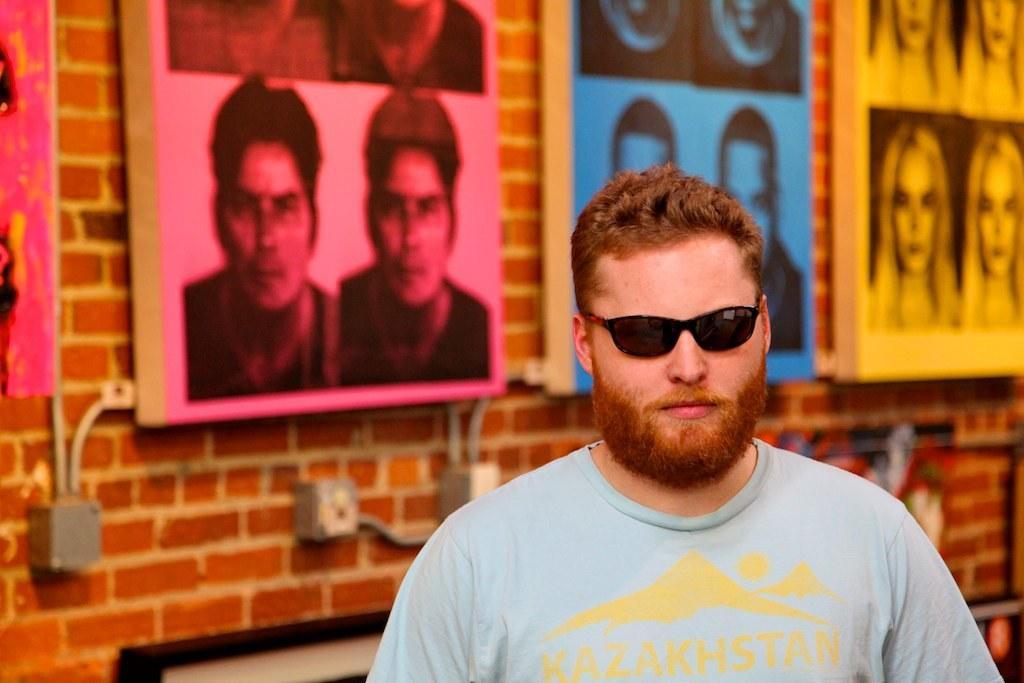Can you describe this image briefly? A man is wearing clothes and goggles, there are photo frames of men and women on the wall. 